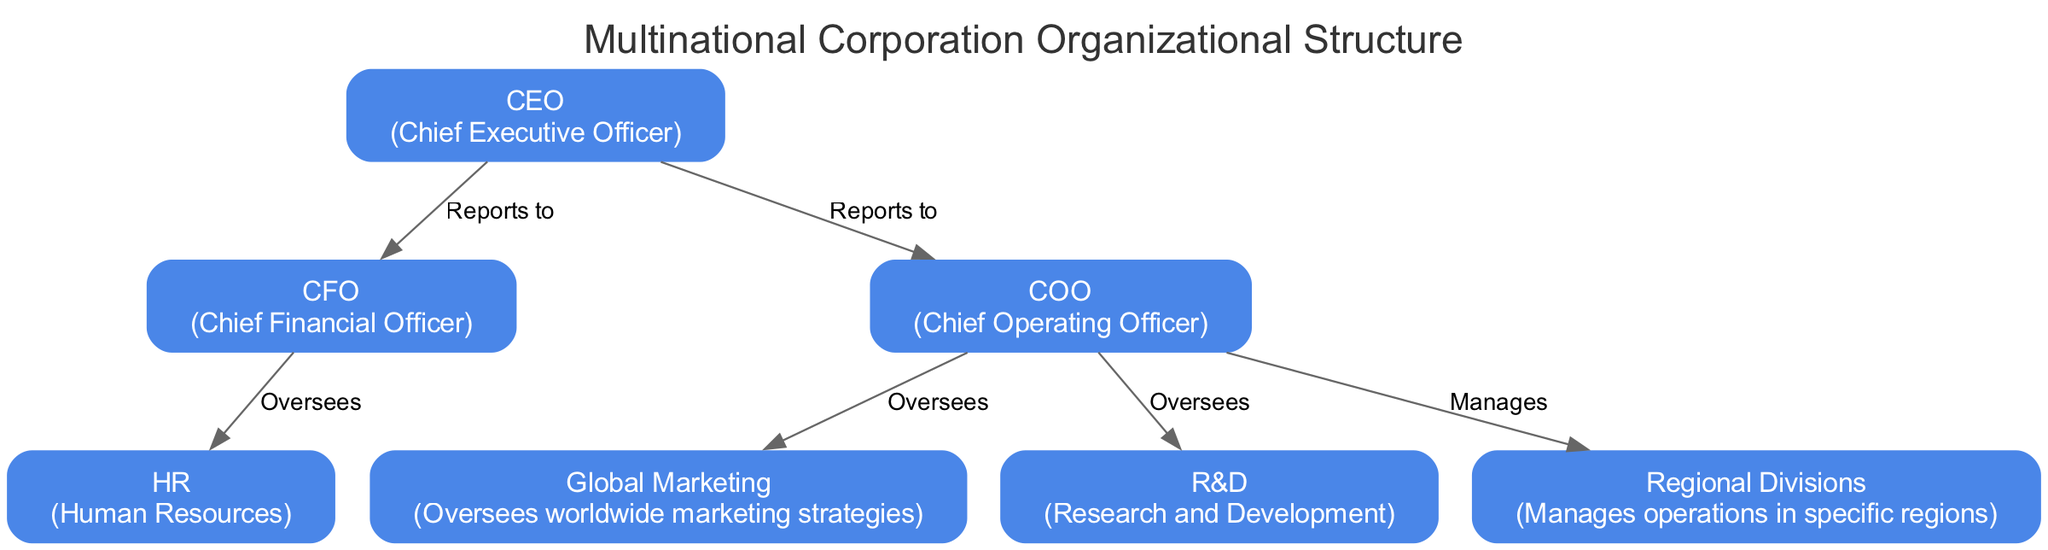What is the title of the diagram? The title of the diagram is stated as "Multinational Corporation Organizational Structure." This information is usually displayed at the top of the diagram.
Answer: Multinational Corporation Organizational Structure Who does the CFO report to? In the diagram, there is an edge labeled "Reports to" that goes from the CFO to the CEO. This indicates that the CFO reports directly to the CEO.
Answer: CEO How many total nodes are in the diagram? The diagram includes a list of nodes representing different positions and departments. By counting them, we find there are seven nodes in total.
Answer: 7 Which department does the COO oversee? The COO has directed edges labeled "Oversees" that lead to Global Marketing and R&D, indicating that the COO oversees both of these departments. To answer the question, either department could be stated, but both must be named for clarity.
Answer: Global Marketing and R&D What is the relationship between the COO and Regional Divisions? The diagram shows that the COO has a directed edge labeled "Manages" that goes to the Regional Divisions. This indicates the COO manages the operations of the Regional Divisions.
Answer: Manages Which position oversees Human Resources? The diagram states that the CFO oversees the HR department, as indicated by the edge labeled "Oversees" coming from the CFO to HR.
Answer: CFO How many edges are present in the diagram? The edges represent the relationships between positions and departments. By counting all the edges in the diagram, there are six edges connecting various nodes.
Answer: 6 Which position does the CEO supervise directly? The CEO has two direct reports, the CFO and the COO, which indicates that both of these positions report directly to the CEO.
Answer: CFO and COO What does the HR department manage? In the diagram, the HR department does not directly manage any other department, but it is overseen by the CFO. Thus, HR's specific management role is not indicated in the diagram.
Answer: None (HR does not manage any) What is the primary role of the Global Marketing department? According to the diagram, the Global Marketing department is described as overseeing worldwide marketing strategies, emphasizing its role in global marketing efforts.
Answer: Oversees worldwide marketing strategies 